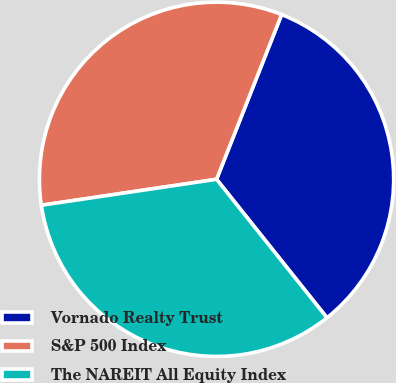Convert chart to OTSL. <chart><loc_0><loc_0><loc_500><loc_500><pie_chart><fcel>Vornado Realty Trust<fcel>S&P 500 Index<fcel>The NAREIT All Equity Index<nl><fcel>33.3%<fcel>33.33%<fcel>33.37%<nl></chart> 